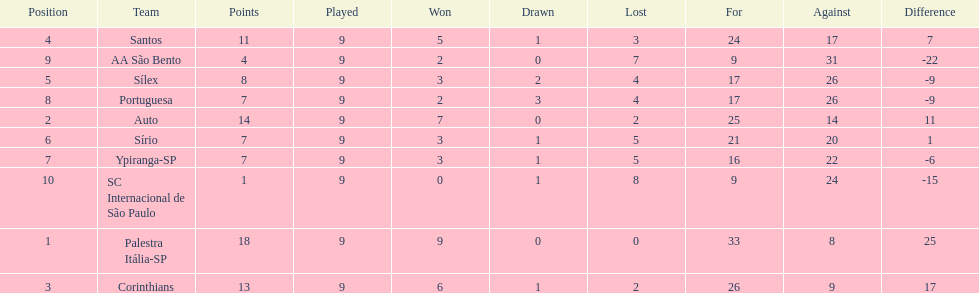In 1926 brazilian football,aside from the first place team, what other teams had winning records? Auto, Corinthians, Santos. Write the full table. {'header': ['Position', 'Team', 'Points', 'Played', 'Won', 'Drawn', 'Lost', 'For', 'Against', 'Difference'], 'rows': [['4', 'Santos', '11', '9', '5', '1', '3', '24', '17', '7'], ['9', 'AA São Bento', '4', '9', '2', '0', '7', '9', '31', '-22'], ['5', 'Sílex', '8', '9', '3', '2', '4', '17', '26', '-9'], ['8', 'Portuguesa', '7', '9', '2', '3', '4', '17', '26', '-9'], ['2', 'Auto', '14', '9', '7', '0', '2', '25', '14', '11'], ['6', 'Sírio', '7', '9', '3', '1', '5', '21', '20', '1'], ['7', 'Ypiranga-SP', '7', '9', '3', '1', '5', '16', '22', '-6'], ['10', 'SC Internacional de São Paulo', '1', '9', '0', '1', '8', '9', '24', '-15'], ['1', 'Palestra Itália-SP', '18', '9', '9', '0', '0', '33', '8', '25'], ['3', 'Corinthians', '13', '9', '6', '1', '2', '26', '9', '17']]} 